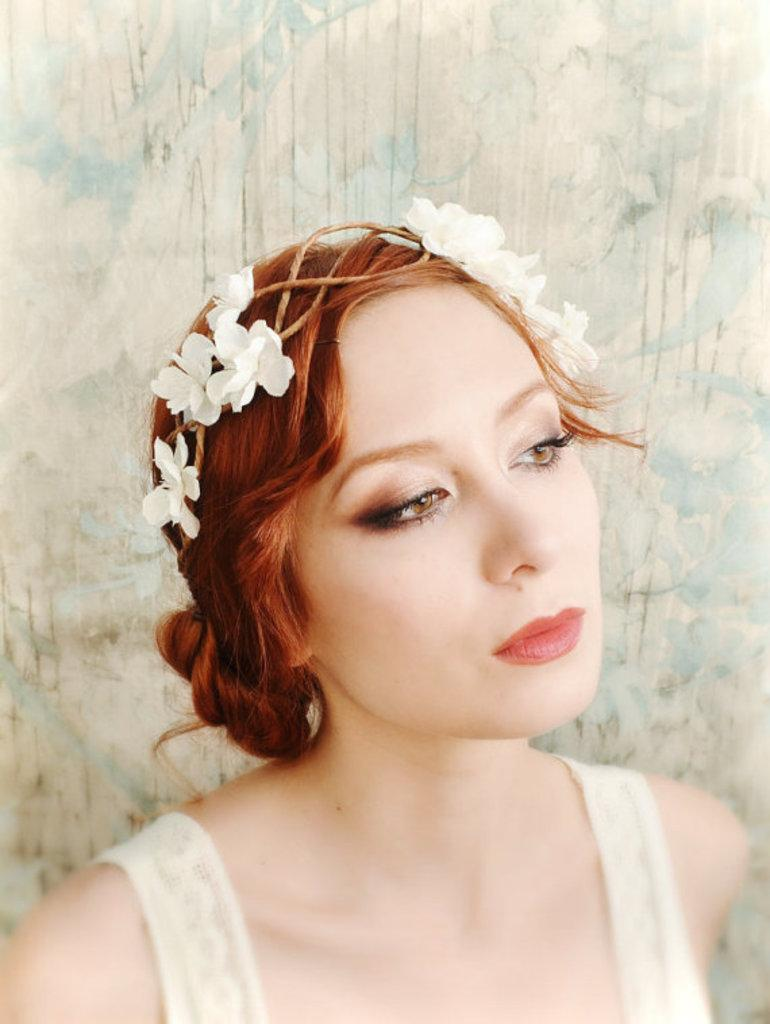Who is the main subject in the image? There is a woman in the image. What is the woman wearing? The woman is wearing a white dress. Are there any accessories or decorations on the woman? Yes, there are white-colored flowers on the woman's head. What is the color of the background in the image? The background of the image is white. Can you tell me how many kites are being flown by the woman in the image? There are no kites present in the image; the woman is wearing a white dress and has white-colored flowers on her head. Is there a band playing in the background of the image? There is no band present in the image; the background is white. 